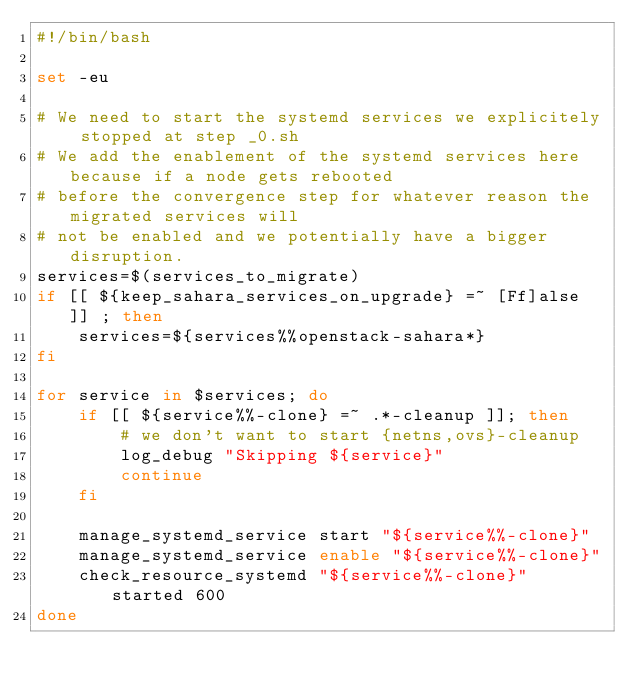Convert code to text. <code><loc_0><loc_0><loc_500><loc_500><_Bash_>#!/bin/bash

set -eu

# We need to start the systemd services we explicitely stopped at step _0.sh
# We add the enablement of the systemd services here because if a node gets rebooted
# before the convergence step for whatever reason the migrated services will
# not be enabled and we potentially have a bigger disruption.
services=$(services_to_migrate)
if [[ ${keep_sahara_services_on_upgrade} =~ [Ff]alse ]] ; then
    services=${services%%openstack-sahara*}
fi

for service in $services; do
    if [[ ${service%%-clone} =~ .*-cleanup ]]; then
        # we don't want to start {netns,ovs}-cleanup
        log_debug "Skipping ${service}"
        continue
    fi

    manage_systemd_service start "${service%%-clone}"
    manage_systemd_service enable "${service%%-clone}"
    check_resource_systemd "${service%%-clone}" started 600
done
</code> 